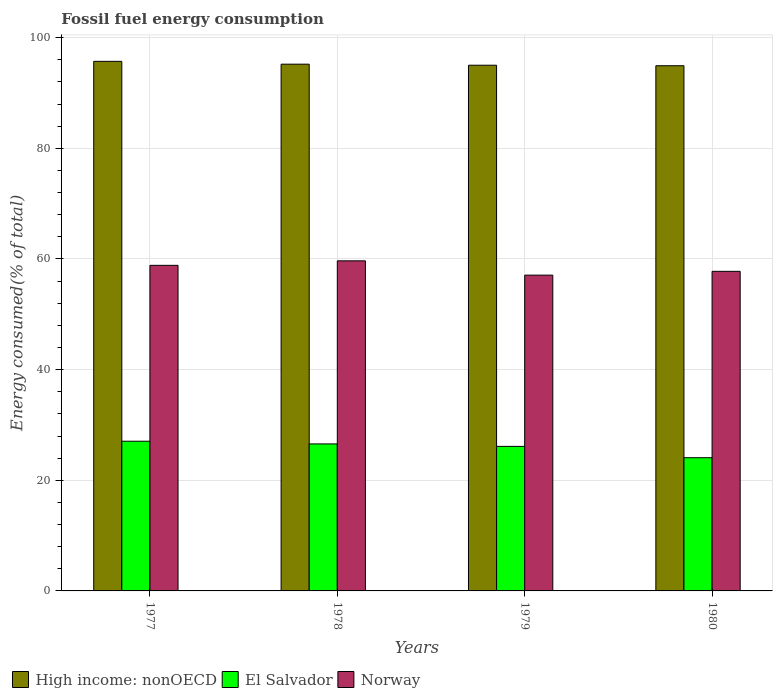How many different coloured bars are there?
Your answer should be very brief. 3. Are the number of bars per tick equal to the number of legend labels?
Make the answer very short. Yes. How many bars are there on the 2nd tick from the left?
Your answer should be very brief. 3. How many bars are there on the 3rd tick from the right?
Make the answer very short. 3. What is the label of the 1st group of bars from the left?
Offer a very short reply. 1977. What is the percentage of energy consumed in El Salvador in 1980?
Offer a very short reply. 24.08. Across all years, what is the maximum percentage of energy consumed in Norway?
Offer a terse response. 59.66. Across all years, what is the minimum percentage of energy consumed in High income: nonOECD?
Ensure brevity in your answer.  94.93. What is the total percentage of energy consumed in High income: nonOECD in the graph?
Ensure brevity in your answer.  380.87. What is the difference between the percentage of energy consumed in El Salvador in 1978 and that in 1980?
Provide a succinct answer. 2.49. What is the difference between the percentage of energy consumed in Norway in 1979 and the percentage of energy consumed in El Salvador in 1980?
Offer a terse response. 33. What is the average percentage of energy consumed in El Salvador per year?
Keep it short and to the point. 25.96. In the year 1980, what is the difference between the percentage of energy consumed in Norway and percentage of energy consumed in High income: nonOECD?
Ensure brevity in your answer.  -37.16. In how many years, is the percentage of energy consumed in Norway greater than 96 %?
Your answer should be very brief. 0. What is the ratio of the percentage of energy consumed in High income: nonOECD in 1977 to that in 1980?
Make the answer very short. 1.01. Is the percentage of energy consumed in High income: nonOECD in 1979 less than that in 1980?
Provide a succinct answer. No. Is the difference between the percentage of energy consumed in Norway in 1978 and 1979 greater than the difference between the percentage of energy consumed in High income: nonOECD in 1978 and 1979?
Your answer should be very brief. Yes. What is the difference between the highest and the second highest percentage of energy consumed in El Salvador?
Your answer should be very brief. 0.49. What is the difference between the highest and the lowest percentage of energy consumed in High income: nonOECD?
Keep it short and to the point. 0.79. In how many years, is the percentage of energy consumed in Norway greater than the average percentage of energy consumed in Norway taken over all years?
Your answer should be compact. 2. What does the 3rd bar from the left in 1978 represents?
Your answer should be compact. Norway. What does the 2nd bar from the right in 1978 represents?
Keep it short and to the point. El Salvador. Is it the case that in every year, the sum of the percentage of energy consumed in El Salvador and percentage of energy consumed in Norway is greater than the percentage of energy consumed in High income: nonOECD?
Your answer should be very brief. No. How many bars are there?
Make the answer very short. 12. Are all the bars in the graph horizontal?
Make the answer very short. No. How many years are there in the graph?
Your answer should be compact. 4. Does the graph contain grids?
Give a very brief answer. Yes. How many legend labels are there?
Keep it short and to the point. 3. What is the title of the graph?
Provide a succinct answer. Fossil fuel energy consumption. What is the label or title of the X-axis?
Give a very brief answer. Years. What is the label or title of the Y-axis?
Offer a very short reply. Energy consumed(% of total). What is the Energy consumed(% of total) in High income: nonOECD in 1977?
Ensure brevity in your answer.  95.72. What is the Energy consumed(% of total) in El Salvador in 1977?
Make the answer very short. 27.06. What is the Energy consumed(% of total) in Norway in 1977?
Provide a short and direct response. 58.85. What is the Energy consumed(% of total) in High income: nonOECD in 1978?
Ensure brevity in your answer.  95.21. What is the Energy consumed(% of total) in El Salvador in 1978?
Ensure brevity in your answer.  26.57. What is the Energy consumed(% of total) in Norway in 1978?
Your answer should be compact. 59.66. What is the Energy consumed(% of total) of High income: nonOECD in 1979?
Give a very brief answer. 95.02. What is the Energy consumed(% of total) in El Salvador in 1979?
Provide a succinct answer. 26.13. What is the Energy consumed(% of total) in Norway in 1979?
Make the answer very short. 57.08. What is the Energy consumed(% of total) of High income: nonOECD in 1980?
Make the answer very short. 94.93. What is the Energy consumed(% of total) in El Salvador in 1980?
Give a very brief answer. 24.08. What is the Energy consumed(% of total) in Norway in 1980?
Provide a short and direct response. 57.77. Across all years, what is the maximum Energy consumed(% of total) in High income: nonOECD?
Give a very brief answer. 95.72. Across all years, what is the maximum Energy consumed(% of total) of El Salvador?
Your response must be concise. 27.06. Across all years, what is the maximum Energy consumed(% of total) of Norway?
Offer a terse response. 59.66. Across all years, what is the minimum Energy consumed(% of total) of High income: nonOECD?
Offer a very short reply. 94.93. Across all years, what is the minimum Energy consumed(% of total) in El Salvador?
Your answer should be compact. 24.08. Across all years, what is the minimum Energy consumed(% of total) in Norway?
Keep it short and to the point. 57.08. What is the total Energy consumed(% of total) in High income: nonOECD in the graph?
Your answer should be very brief. 380.87. What is the total Energy consumed(% of total) in El Salvador in the graph?
Your response must be concise. 103.83. What is the total Energy consumed(% of total) in Norway in the graph?
Your answer should be compact. 233.36. What is the difference between the Energy consumed(% of total) of High income: nonOECD in 1977 and that in 1978?
Provide a short and direct response. 0.51. What is the difference between the Energy consumed(% of total) of El Salvador in 1977 and that in 1978?
Provide a succinct answer. 0.49. What is the difference between the Energy consumed(% of total) in Norway in 1977 and that in 1978?
Offer a very short reply. -0.82. What is the difference between the Energy consumed(% of total) of High income: nonOECD in 1977 and that in 1979?
Keep it short and to the point. 0.7. What is the difference between the Energy consumed(% of total) of El Salvador in 1977 and that in 1979?
Offer a terse response. 0.93. What is the difference between the Energy consumed(% of total) of Norway in 1977 and that in 1979?
Give a very brief answer. 1.77. What is the difference between the Energy consumed(% of total) in High income: nonOECD in 1977 and that in 1980?
Ensure brevity in your answer.  0.79. What is the difference between the Energy consumed(% of total) of El Salvador in 1977 and that in 1980?
Your answer should be very brief. 2.98. What is the difference between the Energy consumed(% of total) of Norway in 1977 and that in 1980?
Ensure brevity in your answer.  1.08. What is the difference between the Energy consumed(% of total) in High income: nonOECD in 1978 and that in 1979?
Keep it short and to the point. 0.19. What is the difference between the Energy consumed(% of total) of El Salvador in 1978 and that in 1979?
Provide a succinct answer. 0.44. What is the difference between the Energy consumed(% of total) in Norway in 1978 and that in 1979?
Provide a succinct answer. 2.58. What is the difference between the Energy consumed(% of total) of High income: nonOECD in 1978 and that in 1980?
Offer a very short reply. 0.28. What is the difference between the Energy consumed(% of total) in El Salvador in 1978 and that in 1980?
Make the answer very short. 2.49. What is the difference between the Energy consumed(% of total) of Norway in 1978 and that in 1980?
Keep it short and to the point. 1.9. What is the difference between the Energy consumed(% of total) of High income: nonOECD in 1979 and that in 1980?
Offer a terse response. 0.09. What is the difference between the Energy consumed(% of total) of El Salvador in 1979 and that in 1980?
Keep it short and to the point. 2.05. What is the difference between the Energy consumed(% of total) in Norway in 1979 and that in 1980?
Ensure brevity in your answer.  -0.69. What is the difference between the Energy consumed(% of total) of High income: nonOECD in 1977 and the Energy consumed(% of total) of El Salvador in 1978?
Make the answer very short. 69.15. What is the difference between the Energy consumed(% of total) of High income: nonOECD in 1977 and the Energy consumed(% of total) of Norway in 1978?
Make the answer very short. 36.06. What is the difference between the Energy consumed(% of total) of El Salvador in 1977 and the Energy consumed(% of total) of Norway in 1978?
Your answer should be very brief. -32.61. What is the difference between the Energy consumed(% of total) in High income: nonOECD in 1977 and the Energy consumed(% of total) in El Salvador in 1979?
Offer a terse response. 69.59. What is the difference between the Energy consumed(% of total) of High income: nonOECD in 1977 and the Energy consumed(% of total) of Norway in 1979?
Provide a succinct answer. 38.64. What is the difference between the Energy consumed(% of total) of El Salvador in 1977 and the Energy consumed(% of total) of Norway in 1979?
Offer a terse response. -30.02. What is the difference between the Energy consumed(% of total) of High income: nonOECD in 1977 and the Energy consumed(% of total) of El Salvador in 1980?
Your response must be concise. 71.64. What is the difference between the Energy consumed(% of total) of High income: nonOECD in 1977 and the Energy consumed(% of total) of Norway in 1980?
Provide a succinct answer. 37.95. What is the difference between the Energy consumed(% of total) in El Salvador in 1977 and the Energy consumed(% of total) in Norway in 1980?
Your response must be concise. -30.71. What is the difference between the Energy consumed(% of total) of High income: nonOECD in 1978 and the Energy consumed(% of total) of El Salvador in 1979?
Ensure brevity in your answer.  69.08. What is the difference between the Energy consumed(% of total) in High income: nonOECD in 1978 and the Energy consumed(% of total) in Norway in 1979?
Offer a terse response. 38.13. What is the difference between the Energy consumed(% of total) in El Salvador in 1978 and the Energy consumed(% of total) in Norway in 1979?
Make the answer very short. -30.51. What is the difference between the Energy consumed(% of total) of High income: nonOECD in 1978 and the Energy consumed(% of total) of El Salvador in 1980?
Offer a very short reply. 71.13. What is the difference between the Energy consumed(% of total) of High income: nonOECD in 1978 and the Energy consumed(% of total) of Norway in 1980?
Give a very brief answer. 37.44. What is the difference between the Energy consumed(% of total) of El Salvador in 1978 and the Energy consumed(% of total) of Norway in 1980?
Offer a very short reply. -31.2. What is the difference between the Energy consumed(% of total) of High income: nonOECD in 1979 and the Energy consumed(% of total) of El Salvador in 1980?
Provide a succinct answer. 70.94. What is the difference between the Energy consumed(% of total) of High income: nonOECD in 1979 and the Energy consumed(% of total) of Norway in 1980?
Your answer should be compact. 37.25. What is the difference between the Energy consumed(% of total) in El Salvador in 1979 and the Energy consumed(% of total) in Norway in 1980?
Give a very brief answer. -31.64. What is the average Energy consumed(% of total) in High income: nonOECD per year?
Your answer should be compact. 95.22. What is the average Energy consumed(% of total) of El Salvador per year?
Give a very brief answer. 25.96. What is the average Energy consumed(% of total) in Norway per year?
Make the answer very short. 58.34. In the year 1977, what is the difference between the Energy consumed(% of total) of High income: nonOECD and Energy consumed(% of total) of El Salvador?
Offer a terse response. 68.66. In the year 1977, what is the difference between the Energy consumed(% of total) in High income: nonOECD and Energy consumed(% of total) in Norway?
Keep it short and to the point. 36.87. In the year 1977, what is the difference between the Energy consumed(% of total) in El Salvador and Energy consumed(% of total) in Norway?
Make the answer very short. -31.79. In the year 1978, what is the difference between the Energy consumed(% of total) in High income: nonOECD and Energy consumed(% of total) in El Salvador?
Offer a very short reply. 68.64. In the year 1978, what is the difference between the Energy consumed(% of total) in High income: nonOECD and Energy consumed(% of total) in Norway?
Offer a very short reply. 35.55. In the year 1978, what is the difference between the Energy consumed(% of total) of El Salvador and Energy consumed(% of total) of Norway?
Give a very brief answer. -33.09. In the year 1979, what is the difference between the Energy consumed(% of total) in High income: nonOECD and Energy consumed(% of total) in El Salvador?
Ensure brevity in your answer.  68.89. In the year 1979, what is the difference between the Energy consumed(% of total) of High income: nonOECD and Energy consumed(% of total) of Norway?
Give a very brief answer. 37.94. In the year 1979, what is the difference between the Energy consumed(% of total) in El Salvador and Energy consumed(% of total) in Norway?
Your response must be concise. -30.95. In the year 1980, what is the difference between the Energy consumed(% of total) in High income: nonOECD and Energy consumed(% of total) in El Salvador?
Your answer should be compact. 70.85. In the year 1980, what is the difference between the Energy consumed(% of total) of High income: nonOECD and Energy consumed(% of total) of Norway?
Provide a succinct answer. 37.16. In the year 1980, what is the difference between the Energy consumed(% of total) of El Salvador and Energy consumed(% of total) of Norway?
Ensure brevity in your answer.  -33.69. What is the ratio of the Energy consumed(% of total) in High income: nonOECD in 1977 to that in 1978?
Ensure brevity in your answer.  1.01. What is the ratio of the Energy consumed(% of total) of El Salvador in 1977 to that in 1978?
Provide a succinct answer. 1.02. What is the ratio of the Energy consumed(% of total) in Norway in 1977 to that in 1978?
Keep it short and to the point. 0.99. What is the ratio of the Energy consumed(% of total) of High income: nonOECD in 1977 to that in 1979?
Your response must be concise. 1.01. What is the ratio of the Energy consumed(% of total) of El Salvador in 1977 to that in 1979?
Offer a terse response. 1.04. What is the ratio of the Energy consumed(% of total) in Norway in 1977 to that in 1979?
Provide a short and direct response. 1.03. What is the ratio of the Energy consumed(% of total) of High income: nonOECD in 1977 to that in 1980?
Your answer should be compact. 1.01. What is the ratio of the Energy consumed(% of total) of El Salvador in 1977 to that in 1980?
Ensure brevity in your answer.  1.12. What is the ratio of the Energy consumed(% of total) in Norway in 1977 to that in 1980?
Make the answer very short. 1.02. What is the ratio of the Energy consumed(% of total) of El Salvador in 1978 to that in 1979?
Keep it short and to the point. 1.02. What is the ratio of the Energy consumed(% of total) in Norway in 1978 to that in 1979?
Ensure brevity in your answer.  1.05. What is the ratio of the Energy consumed(% of total) of El Salvador in 1978 to that in 1980?
Offer a very short reply. 1.1. What is the ratio of the Energy consumed(% of total) of Norway in 1978 to that in 1980?
Keep it short and to the point. 1.03. What is the ratio of the Energy consumed(% of total) of El Salvador in 1979 to that in 1980?
Your response must be concise. 1.09. What is the difference between the highest and the second highest Energy consumed(% of total) of High income: nonOECD?
Your answer should be compact. 0.51. What is the difference between the highest and the second highest Energy consumed(% of total) in El Salvador?
Give a very brief answer. 0.49. What is the difference between the highest and the second highest Energy consumed(% of total) in Norway?
Make the answer very short. 0.82. What is the difference between the highest and the lowest Energy consumed(% of total) in High income: nonOECD?
Offer a terse response. 0.79. What is the difference between the highest and the lowest Energy consumed(% of total) of El Salvador?
Offer a terse response. 2.98. What is the difference between the highest and the lowest Energy consumed(% of total) of Norway?
Ensure brevity in your answer.  2.58. 